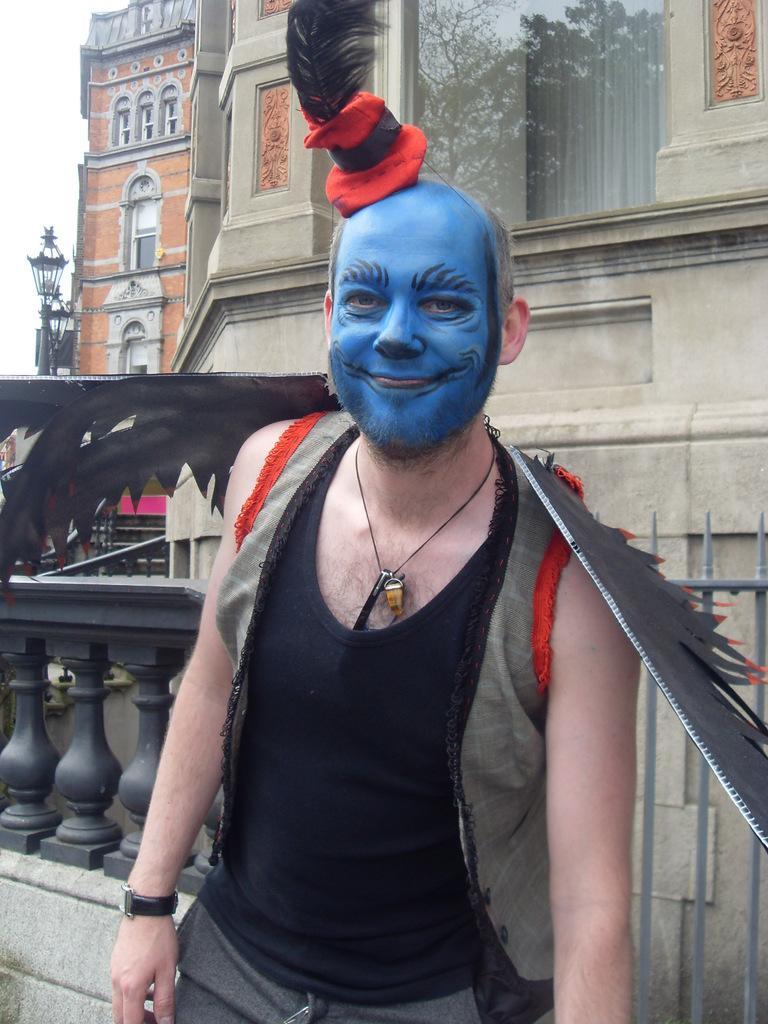Describe this image in one or two sentences. In the center of the image we can see one man standing and he is smiling. And we can see he is in different costume. And we can see blue color paint on his face. In the background we can see buildings, windows, curtains, fences and a few other objects. 